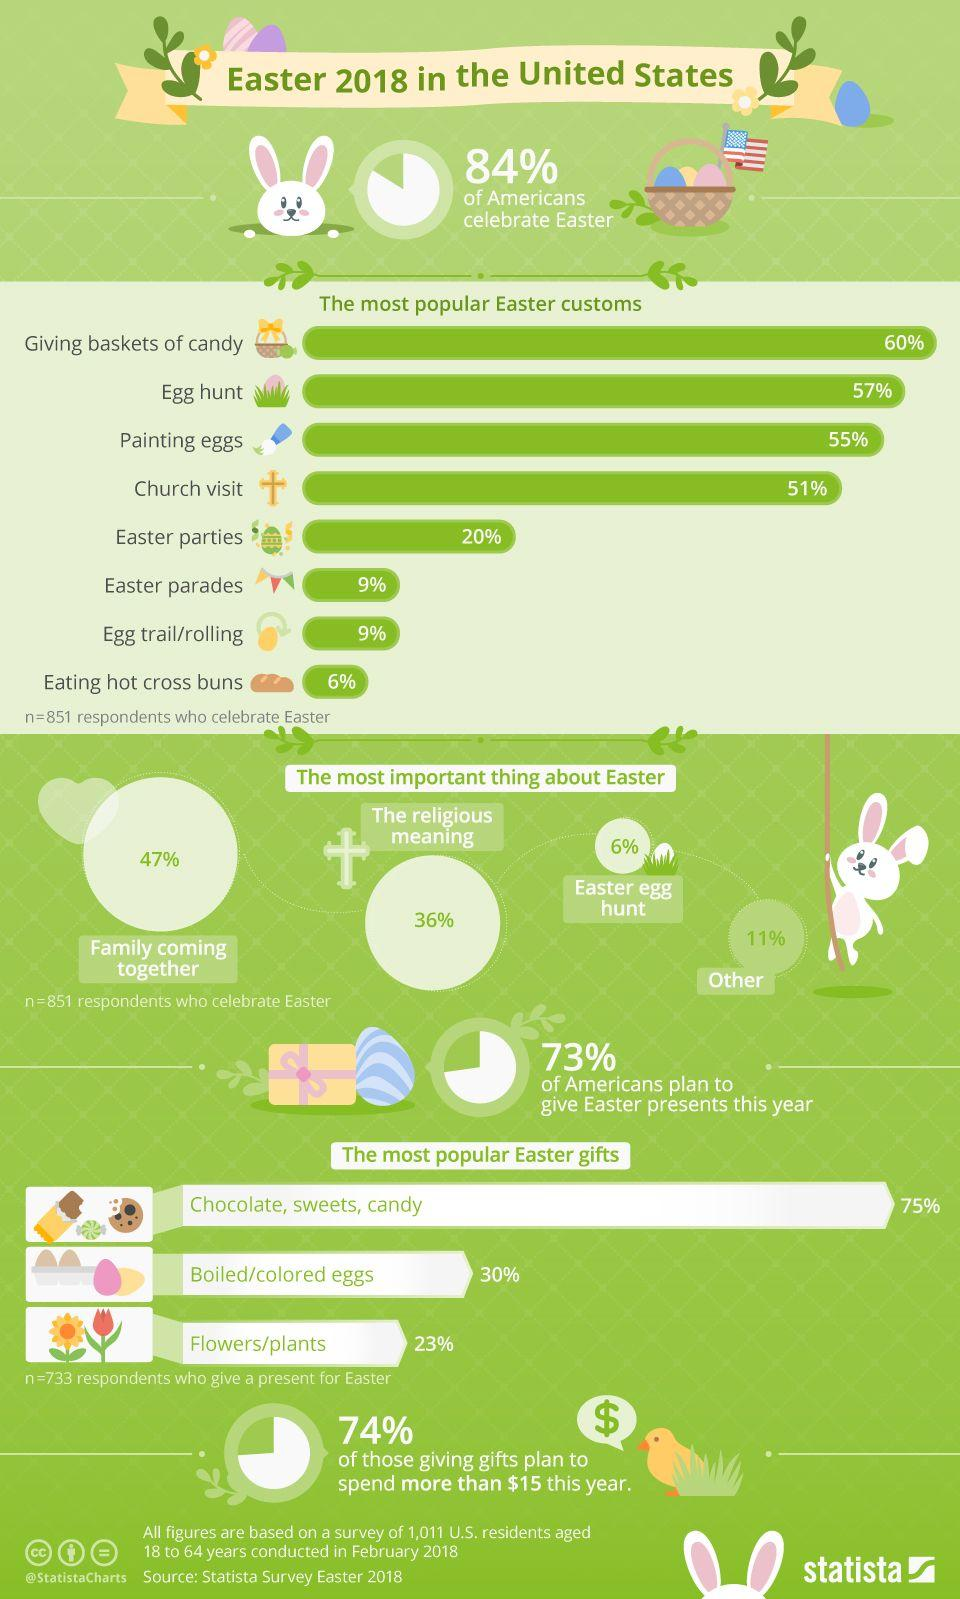Mention a couple of crucial points in this snapshot. In the United States, 47% of families hold family get-together during the Easter holiday. In 2018, it is estimated that approximately 27% of Americans do not plan to give Easter presents. According to a survey, approximately 94% of Americans do not celebrate Easter egg hunts. The average popular Easter gift is boiled or colored eggs. The information graphic lists three different Easter gifts. 